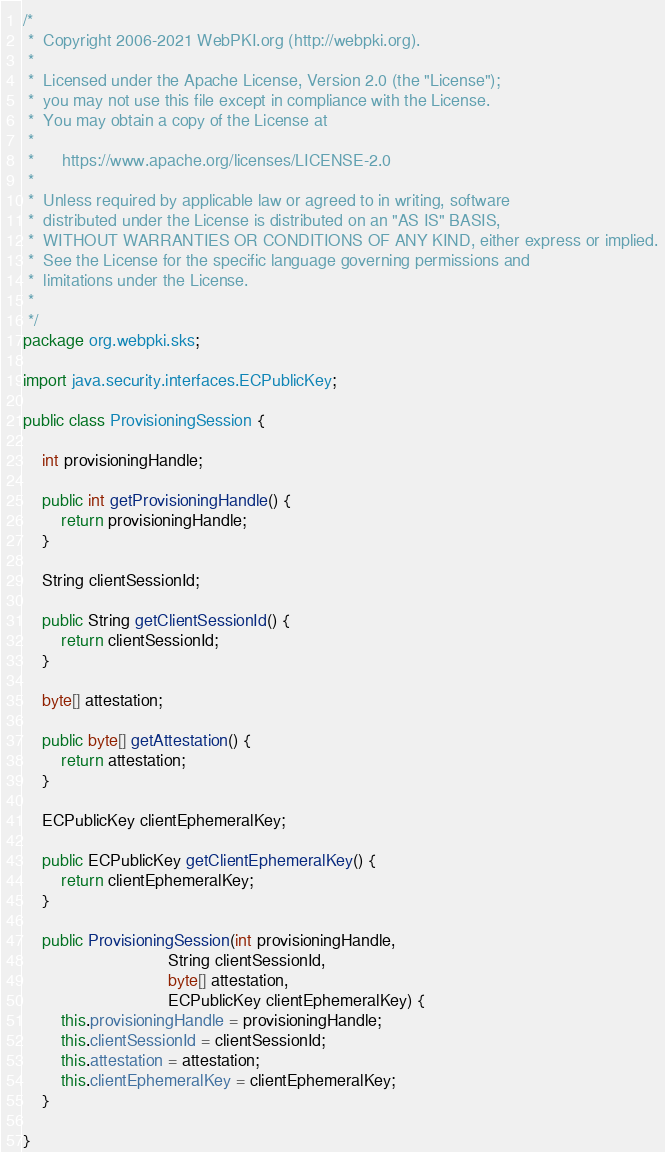Convert code to text. <code><loc_0><loc_0><loc_500><loc_500><_Java_>/*
 *  Copyright 2006-2021 WebPKI.org (http://webpki.org).
 *
 *  Licensed under the Apache License, Version 2.0 (the "License");
 *  you may not use this file except in compliance with the License.
 *  You may obtain a copy of the License at
 *
 *      https://www.apache.org/licenses/LICENSE-2.0
 *
 *  Unless required by applicable law or agreed to in writing, software
 *  distributed under the License is distributed on an "AS IS" BASIS,
 *  WITHOUT WARRANTIES OR CONDITIONS OF ANY KIND, either express or implied.
 *  See the License for the specific language governing permissions and
 *  limitations under the License.
 *
 */
package org.webpki.sks;

import java.security.interfaces.ECPublicKey;

public class ProvisioningSession {

    int provisioningHandle;

    public int getProvisioningHandle() {
        return provisioningHandle;
    }

    String clientSessionId;

    public String getClientSessionId() {
        return clientSessionId;
    }

    byte[] attestation;

    public byte[] getAttestation() {
        return attestation;
    }

    ECPublicKey clientEphemeralKey;

    public ECPublicKey getClientEphemeralKey() {
        return clientEphemeralKey;
    }

    public ProvisioningSession(int provisioningHandle,
                               String clientSessionId,
                               byte[] attestation,
                               ECPublicKey clientEphemeralKey) {
        this.provisioningHandle = provisioningHandle;
        this.clientSessionId = clientSessionId;
        this.attestation = attestation;
        this.clientEphemeralKey = clientEphemeralKey;
    }

}
</code> 